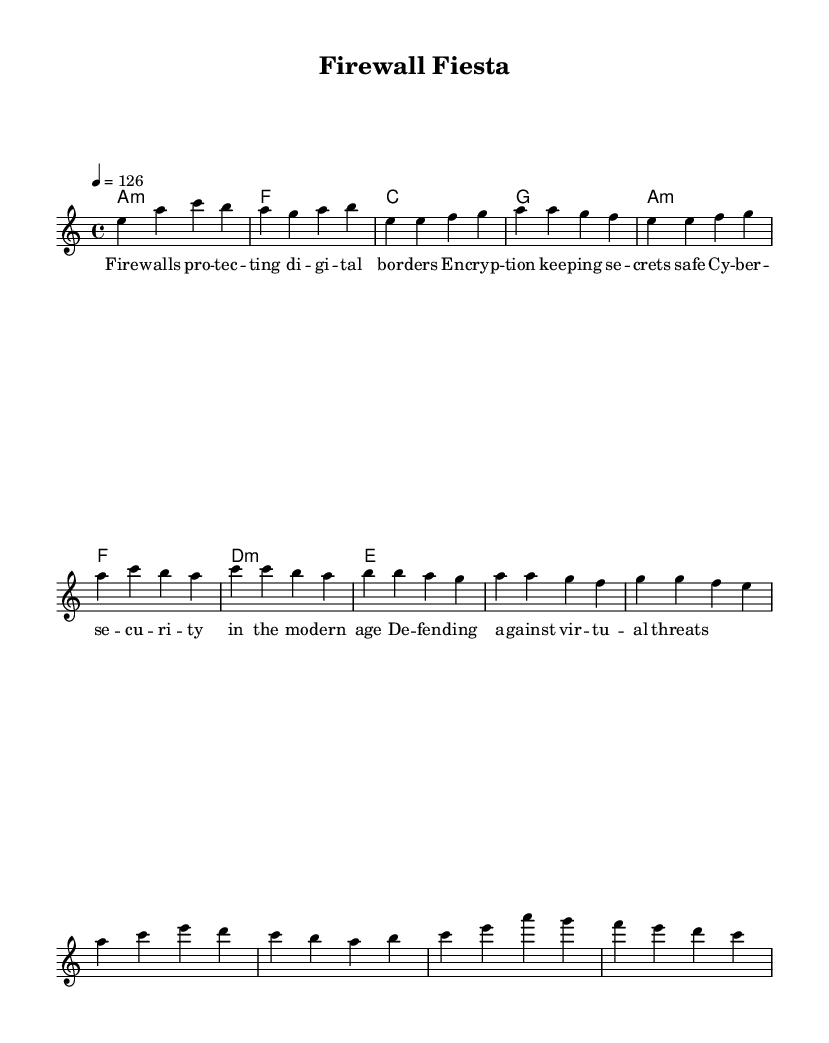What is the key signature of this music? The key signature is A minor, which has no sharps or flats.
Answer: A minor What is the time signature of this music? The time signature is 4/4, meaning there are four beats in each measure.
Answer: 4/4 What is the tempo of the piece? The tempo is indicated as 126 beats per minute, which sets the speed of the music.
Answer: 126 What is the title of the piece? The title given in the header of the sheet music is "Firewall Fiesta."
Answer: Firewall Fiesta How many measures are there in the verse? The verse consists of four measures, as counted within the melody section.
Answer: Four measures What theme is prevalent in the lyrics? The lyrics focus on cybersecurity themes, highlighting aspects such as protection and encryption.
Answer: Cybersecurity Which section comes after the verse? After the verse, the next section is the pre-chorus, as indicated in the structure of the song.
Answer: Pre-Chorus 